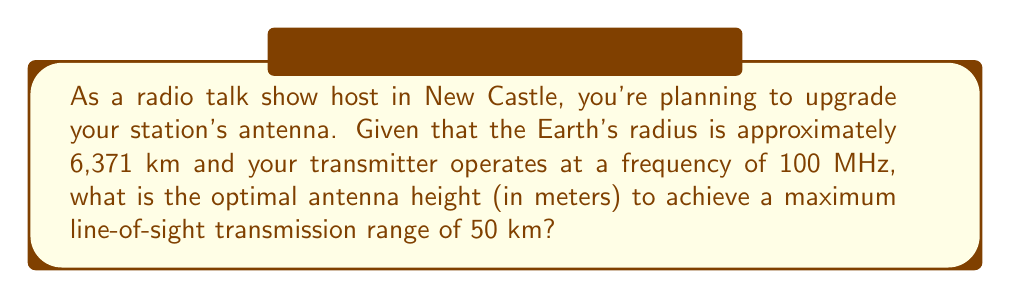Provide a solution to this math problem. To solve this problem, we'll use the formula for the maximum line-of-sight distance between an antenna and the horizon, considering the curvature of the Earth. The steps are as follows:

1. The formula for the maximum line-of-sight distance (d) is:

   $$d = \sqrt{2Rh}$$

   Where R is the Earth's radius and h is the antenna height.

2. We're given:
   R = 6,371 km = 6,371,000 m
   d = 50 km = 50,000 m

3. Substituting these values into the formula:

   $$50,000 = \sqrt{2 \cdot 6,371,000 \cdot h}$$

4. Square both sides:

   $$(50,000)^2 = 2 \cdot 6,371,000 \cdot h$$

5. Simplify:

   $$2,500,000,000 = 12,742,000 \cdot h$$

6. Solve for h:

   $$h = \frac{2,500,000,000}{12,742,000} \approx 196.2 \text{ m}$$

7. Round to the nearest meter:

   h ≈ 196 m

Note: This calculation doesn't account for atmospheric refraction, which can slightly increase the effective range. Also, the actual transmission range may be affected by factors such as transmitter power, receiver sensitivity, and local terrain.
Answer: 196 m 